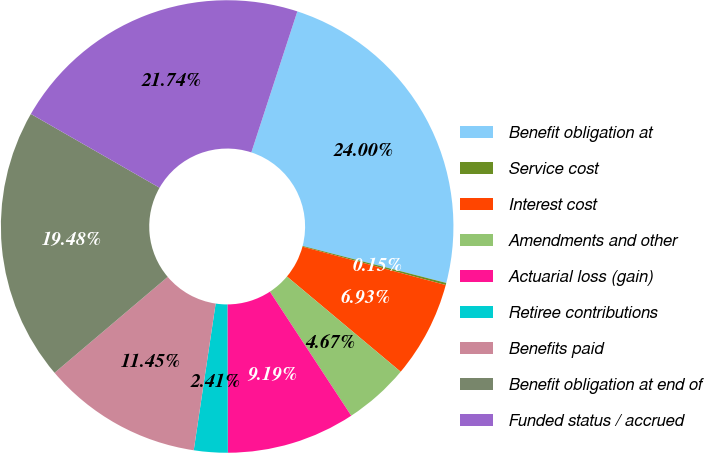Convert chart to OTSL. <chart><loc_0><loc_0><loc_500><loc_500><pie_chart><fcel>Benefit obligation at<fcel>Service cost<fcel>Interest cost<fcel>Amendments and other<fcel>Actuarial loss (gain)<fcel>Retiree contributions<fcel>Benefits paid<fcel>Benefit obligation at end of<fcel>Funded status / accrued<nl><fcel>24.0%<fcel>0.15%<fcel>6.93%<fcel>4.67%<fcel>9.19%<fcel>2.41%<fcel>11.45%<fcel>19.48%<fcel>21.74%<nl></chart> 